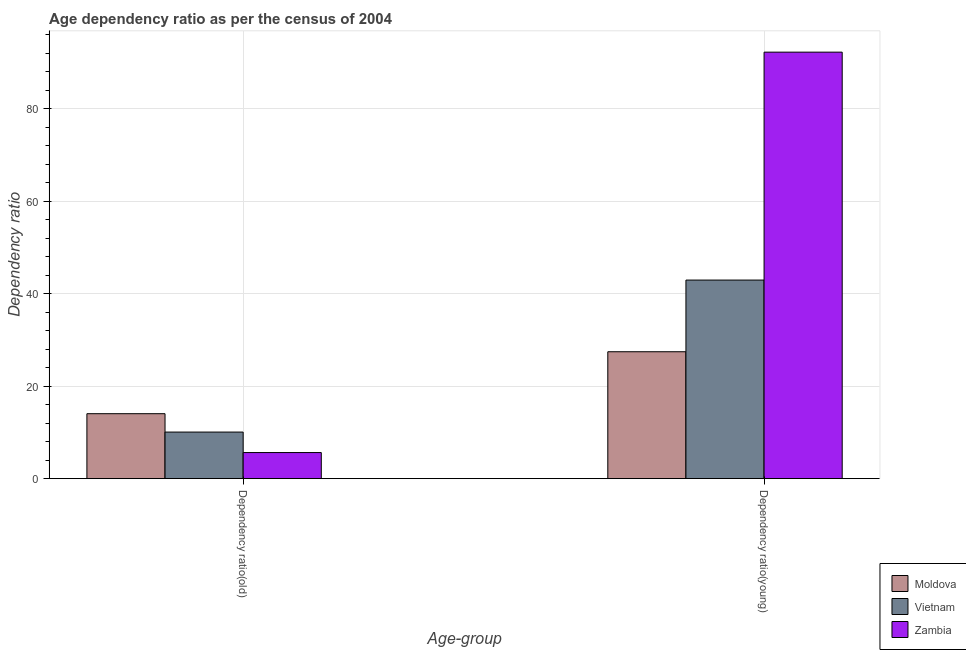How many different coloured bars are there?
Your answer should be very brief. 3. How many groups of bars are there?
Your response must be concise. 2. Are the number of bars per tick equal to the number of legend labels?
Ensure brevity in your answer.  Yes. Are the number of bars on each tick of the X-axis equal?
Keep it short and to the point. Yes. How many bars are there on the 1st tick from the right?
Keep it short and to the point. 3. What is the label of the 1st group of bars from the left?
Provide a short and direct response. Dependency ratio(old). What is the age dependency ratio(old) in Zambia?
Your response must be concise. 5.64. Across all countries, what is the maximum age dependency ratio(old)?
Give a very brief answer. 14.04. Across all countries, what is the minimum age dependency ratio(young)?
Provide a succinct answer. 27.43. In which country was the age dependency ratio(old) maximum?
Provide a succinct answer. Moldova. In which country was the age dependency ratio(old) minimum?
Your answer should be very brief. Zambia. What is the total age dependency ratio(old) in the graph?
Give a very brief answer. 29.74. What is the difference between the age dependency ratio(young) in Zambia and that in Vietnam?
Give a very brief answer. 49.28. What is the difference between the age dependency ratio(old) in Zambia and the age dependency ratio(young) in Vietnam?
Your answer should be very brief. -37.29. What is the average age dependency ratio(young) per country?
Keep it short and to the point. 54.19. What is the difference between the age dependency ratio(old) and age dependency ratio(young) in Vietnam?
Make the answer very short. -32.87. In how many countries, is the age dependency ratio(young) greater than 80 ?
Offer a terse response. 1. What is the ratio of the age dependency ratio(old) in Zambia to that in Moldova?
Your answer should be very brief. 0.4. Is the age dependency ratio(young) in Vietnam less than that in Zambia?
Provide a succinct answer. Yes. In how many countries, is the age dependency ratio(young) greater than the average age dependency ratio(young) taken over all countries?
Offer a terse response. 1. What does the 2nd bar from the left in Dependency ratio(old) represents?
Provide a short and direct response. Vietnam. What does the 3rd bar from the right in Dependency ratio(old) represents?
Provide a succinct answer. Moldova. How many bars are there?
Offer a terse response. 6. How many countries are there in the graph?
Provide a short and direct response. 3. What is the difference between two consecutive major ticks on the Y-axis?
Offer a terse response. 20. How many legend labels are there?
Ensure brevity in your answer.  3. What is the title of the graph?
Provide a succinct answer. Age dependency ratio as per the census of 2004. What is the label or title of the X-axis?
Make the answer very short. Age-group. What is the label or title of the Y-axis?
Provide a succinct answer. Dependency ratio. What is the Dependency ratio in Moldova in Dependency ratio(old)?
Your answer should be very brief. 14.04. What is the Dependency ratio of Vietnam in Dependency ratio(old)?
Ensure brevity in your answer.  10.06. What is the Dependency ratio in Zambia in Dependency ratio(old)?
Provide a succinct answer. 5.64. What is the Dependency ratio of Moldova in Dependency ratio(young)?
Make the answer very short. 27.43. What is the Dependency ratio of Vietnam in Dependency ratio(young)?
Ensure brevity in your answer.  42.93. What is the Dependency ratio of Zambia in Dependency ratio(young)?
Make the answer very short. 92.21. Across all Age-group, what is the maximum Dependency ratio of Moldova?
Offer a terse response. 27.43. Across all Age-group, what is the maximum Dependency ratio of Vietnam?
Offer a terse response. 42.93. Across all Age-group, what is the maximum Dependency ratio in Zambia?
Your response must be concise. 92.21. Across all Age-group, what is the minimum Dependency ratio in Moldova?
Provide a succinct answer. 14.04. Across all Age-group, what is the minimum Dependency ratio in Vietnam?
Provide a succinct answer. 10.06. Across all Age-group, what is the minimum Dependency ratio in Zambia?
Offer a terse response. 5.64. What is the total Dependency ratio of Moldova in the graph?
Offer a terse response. 41.47. What is the total Dependency ratio of Vietnam in the graph?
Offer a very short reply. 52.99. What is the total Dependency ratio of Zambia in the graph?
Make the answer very short. 97.85. What is the difference between the Dependency ratio in Moldova in Dependency ratio(old) and that in Dependency ratio(young)?
Ensure brevity in your answer.  -13.39. What is the difference between the Dependency ratio in Vietnam in Dependency ratio(old) and that in Dependency ratio(young)?
Your answer should be very brief. -32.87. What is the difference between the Dependency ratio in Zambia in Dependency ratio(old) and that in Dependency ratio(young)?
Ensure brevity in your answer.  -86.57. What is the difference between the Dependency ratio in Moldova in Dependency ratio(old) and the Dependency ratio in Vietnam in Dependency ratio(young)?
Your answer should be compact. -28.89. What is the difference between the Dependency ratio in Moldova in Dependency ratio(old) and the Dependency ratio in Zambia in Dependency ratio(young)?
Your answer should be very brief. -78.17. What is the difference between the Dependency ratio in Vietnam in Dependency ratio(old) and the Dependency ratio in Zambia in Dependency ratio(young)?
Your response must be concise. -82.15. What is the average Dependency ratio in Moldova per Age-group?
Provide a succinct answer. 20.73. What is the average Dependency ratio of Vietnam per Age-group?
Offer a terse response. 26.5. What is the average Dependency ratio in Zambia per Age-group?
Offer a very short reply. 48.92. What is the difference between the Dependency ratio in Moldova and Dependency ratio in Vietnam in Dependency ratio(old)?
Offer a terse response. 3.97. What is the difference between the Dependency ratio of Moldova and Dependency ratio of Zambia in Dependency ratio(old)?
Give a very brief answer. 8.4. What is the difference between the Dependency ratio in Vietnam and Dependency ratio in Zambia in Dependency ratio(old)?
Offer a very short reply. 4.43. What is the difference between the Dependency ratio of Moldova and Dependency ratio of Vietnam in Dependency ratio(young)?
Offer a terse response. -15.5. What is the difference between the Dependency ratio in Moldova and Dependency ratio in Zambia in Dependency ratio(young)?
Your answer should be compact. -64.78. What is the difference between the Dependency ratio in Vietnam and Dependency ratio in Zambia in Dependency ratio(young)?
Offer a very short reply. -49.28. What is the ratio of the Dependency ratio in Moldova in Dependency ratio(old) to that in Dependency ratio(young)?
Make the answer very short. 0.51. What is the ratio of the Dependency ratio of Vietnam in Dependency ratio(old) to that in Dependency ratio(young)?
Offer a very short reply. 0.23. What is the ratio of the Dependency ratio in Zambia in Dependency ratio(old) to that in Dependency ratio(young)?
Offer a very short reply. 0.06. What is the difference between the highest and the second highest Dependency ratio of Moldova?
Offer a terse response. 13.39. What is the difference between the highest and the second highest Dependency ratio of Vietnam?
Provide a short and direct response. 32.87. What is the difference between the highest and the second highest Dependency ratio of Zambia?
Offer a very short reply. 86.57. What is the difference between the highest and the lowest Dependency ratio of Moldova?
Your answer should be compact. 13.39. What is the difference between the highest and the lowest Dependency ratio in Vietnam?
Offer a terse response. 32.87. What is the difference between the highest and the lowest Dependency ratio of Zambia?
Your answer should be very brief. 86.57. 